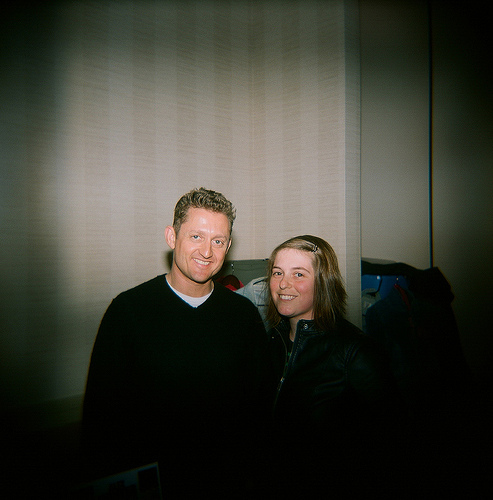<image>
Is the head to the left of the jacket? Yes. From this viewpoint, the head is positioned to the left side relative to the jacket. Is there a jacket next to the jacket? Yes. The jacket is positioned adjacent to the jacket, located nearby in the same general area. 